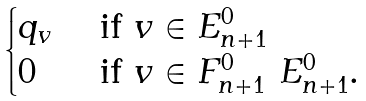<formula> <loc_0><loc_0><loc_500><loc_500>\begin{cases} q _ { v } & \text { if $v \in E_{n+1}^{0}$} \\ 0 & \text { if $v \in F_{n+1}^{0} \ E_{n+1}^{0}$. } \end{cases}</formula> 